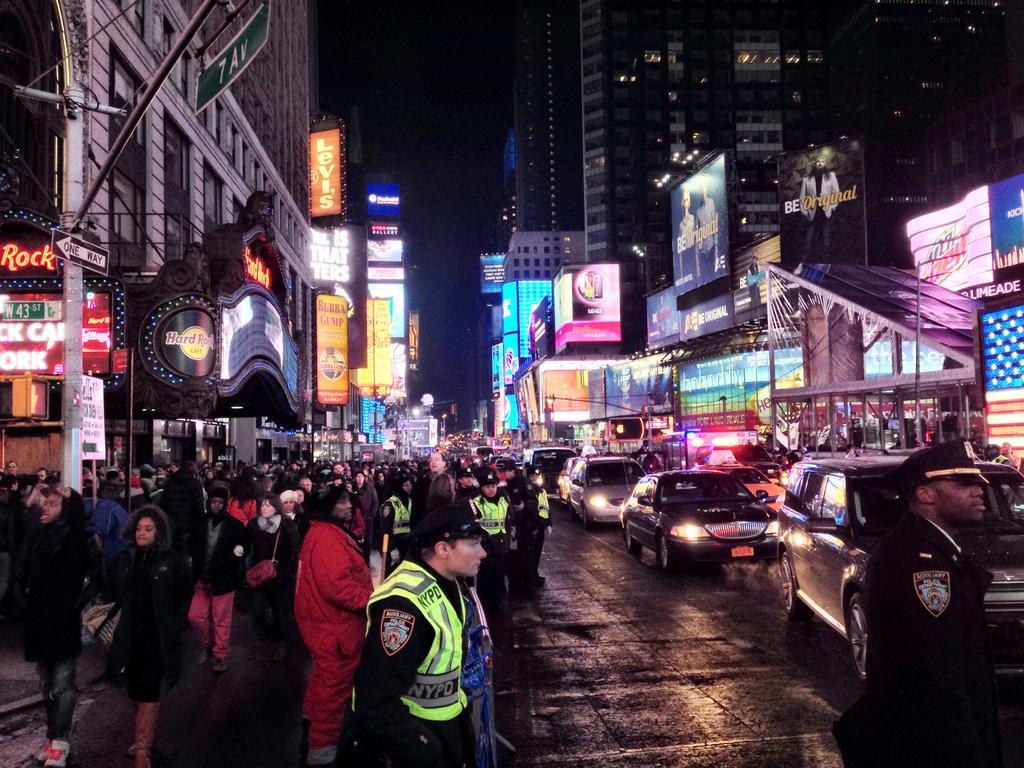Please provide a concise description of this image. In this image, there are a few people and buildings. We can see the ground. There are a few vehicles and poles. We can see some boards with text and display screens. We can also see some signboards and the sky. 